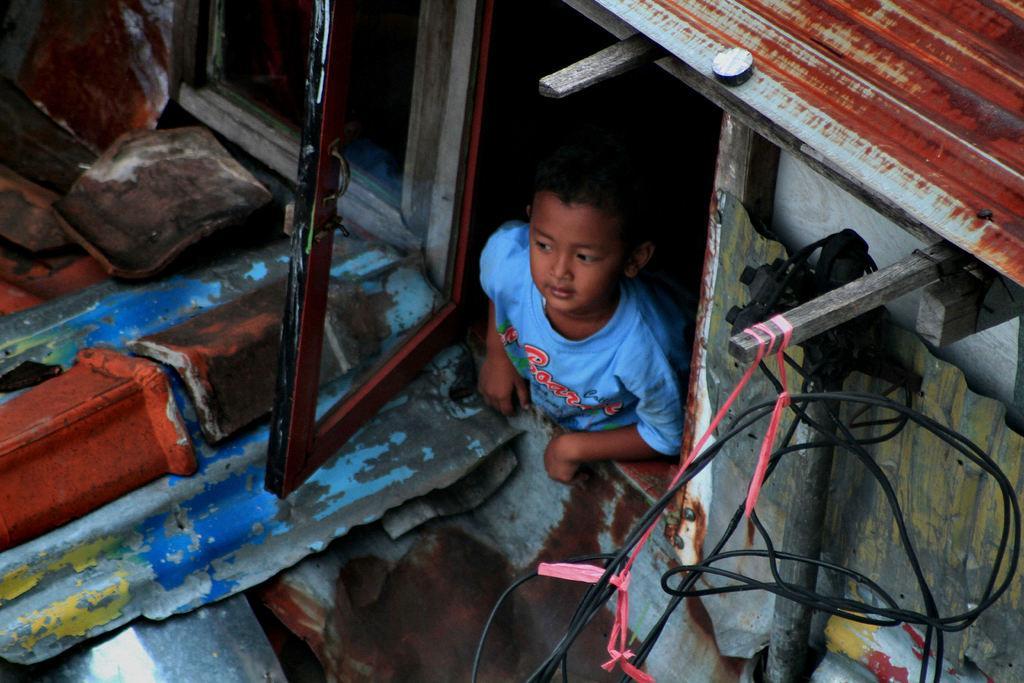In one or two sentences, can you explain what this image depicts? In this image I can see the child with the blue color dress and the child is in the shed. In-front of the the child I can see the metal object and the rocks. To the right I can see the wires. 